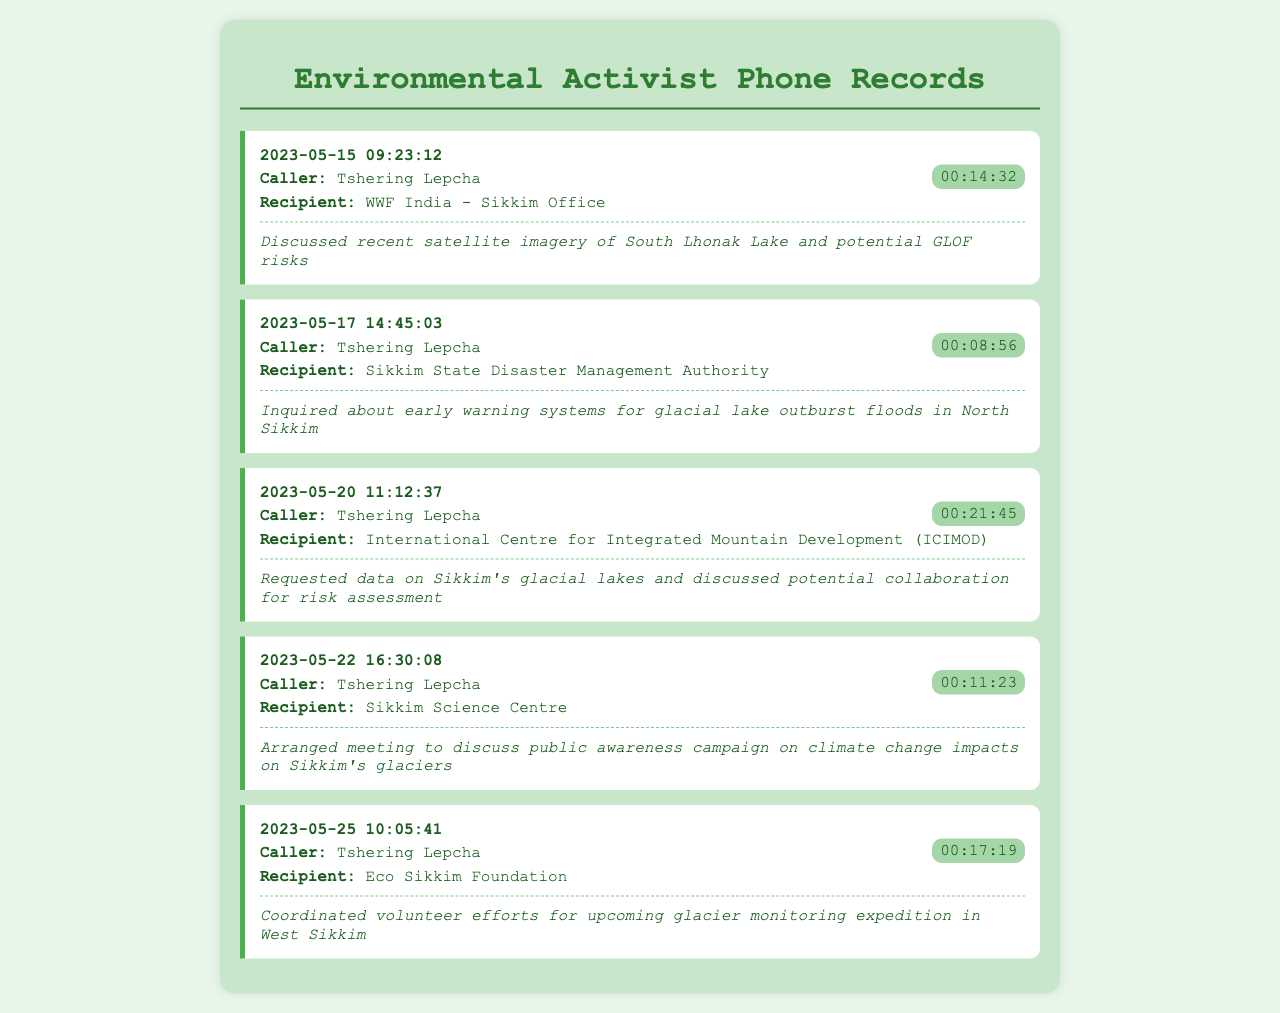what is the date of the first recorded call? The first recorded call in the document is on May 15, 2023.
Answer: May 15, 2023 who called the Sikkim State Disaster Management Authority? The call to the Sikkim State Disaster Management Authority was made by Tshering Lepcha.
Answer: Tshering Lepcha how long was the call with WWF India? The duration of the call with WWF India was 14 minutes and 32 seconds.
Answer: 00:14:32 what was discussed in the call with ICIMOD? In the call with ICIMOD, Tshering Lepcha requested data on Sikkim's glacial lakes and discussed potential collaboration for risk assessment.
Answer: Data on Sikkim's glacial lakes how many calls were made to environmental NGOs? There were five calls made to environmental NGOs in the records.
Answer: Five what is the main focus of Tshering Lepcha's calls? The main focus of Tshering Lepcha's calls is on glacial lake outburst flood risks in Sikkim.
Answer: GLOF risks what was arranged during the call with Sikkim Science Centre? A meeting was arranged to discuss a public awareness campaign on climate change impacts on Sikkim's glaciers.
Answer: Meeting for public awareness campaign how long did the call with Eco Sikkim Foundation last? The call with Eco Sikkim Foundation lasted for 17 minutes and 19 seconds.
Answer: 00:17:19 